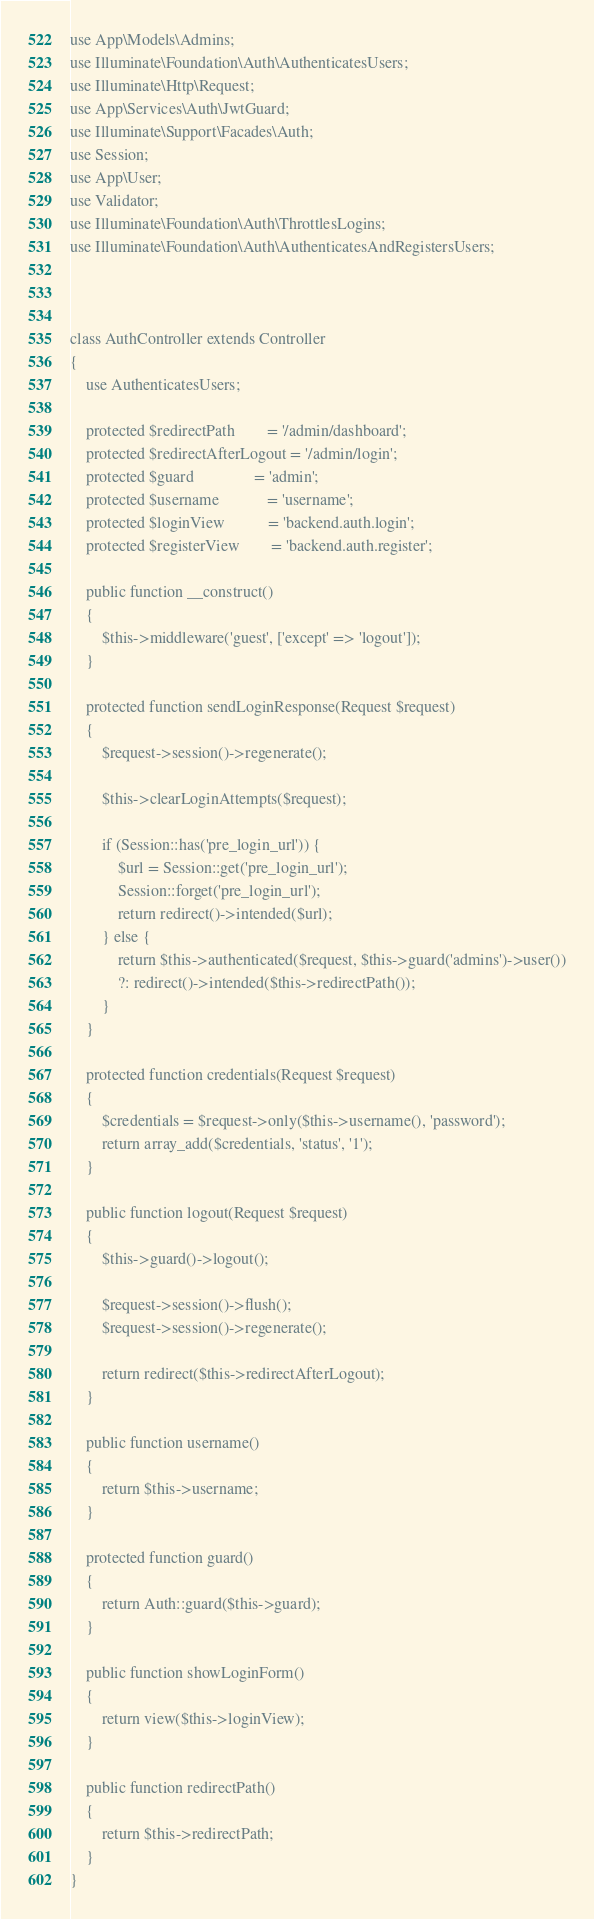Convert code to text. <code><loc_0><loc_0><loc_500><loc_500><_PHP_>use App\Models\Admins;
use Illuminate\Foundation\Auth\AuthenticatesUsers;
use Illuminate\Http\Request;
use App\Services\Auth\JwtGuard;
use Illuminate\Support\Facades\Auth;
use Session;
use App\User;
use Validator;
use Illuminate\Foundation\Auth\ThrottlesLogins;
use Illuminate\Foundation\Auth\AuthenticatesAndRegistersUsers;


 
class AuthController extends Controller
{
    use AuthenticatesUsers;

    protected $redirectPath        = '/admin/dashboard';
    protected $redirectAfterLogout = '/admin/login';
    protected $guard               = 'admin';
    protected $username            = 'username';
    protected $loginView           = 'backend.auth.login';
    protected $registerView        = 'backend.auth.register';

    public function __construct()
    { 
        $this->middleware('guest', ['except' => 'logout']);
    }

    protected function sendLoginResponse(Request $request)
    {
        $request->session()->regenerate();

        $this->clearLoginAttempts($request);

        if (Session::has('pre_login_url')) {
            $url = Session::get('pre_login_url');
            Session::forget('pre_login_url');
            return redirect()->intended($url);
        } else {
            return $this->authenticated($request, $this->guard('admins')->user())
            ?: redirect()->intended($this->redirectPath());
        }
    }

    protected function credentials(Request $request)
    {
        $credentials = $request->only($this->username(), 'password');
        return array_add($credentials, 'status', '1');
    }

    public function logout(Request $request)
    {
        $this->guard()->logout();

        $request->session()->flush();
        $request->session()->regenerate();

        return redirect($this->redirectAfterLogout);
    }

    public function username()
    {
        return $this->username;
    }

    protected function guard()
    {
        return Auth::guard($this->guard);  
    }

    public function showLoginForm()
    {
        return view($this->loginView);
    }

    public function redirectPath()
    {
        return $this->redirectPath;
    }
}
</code> 